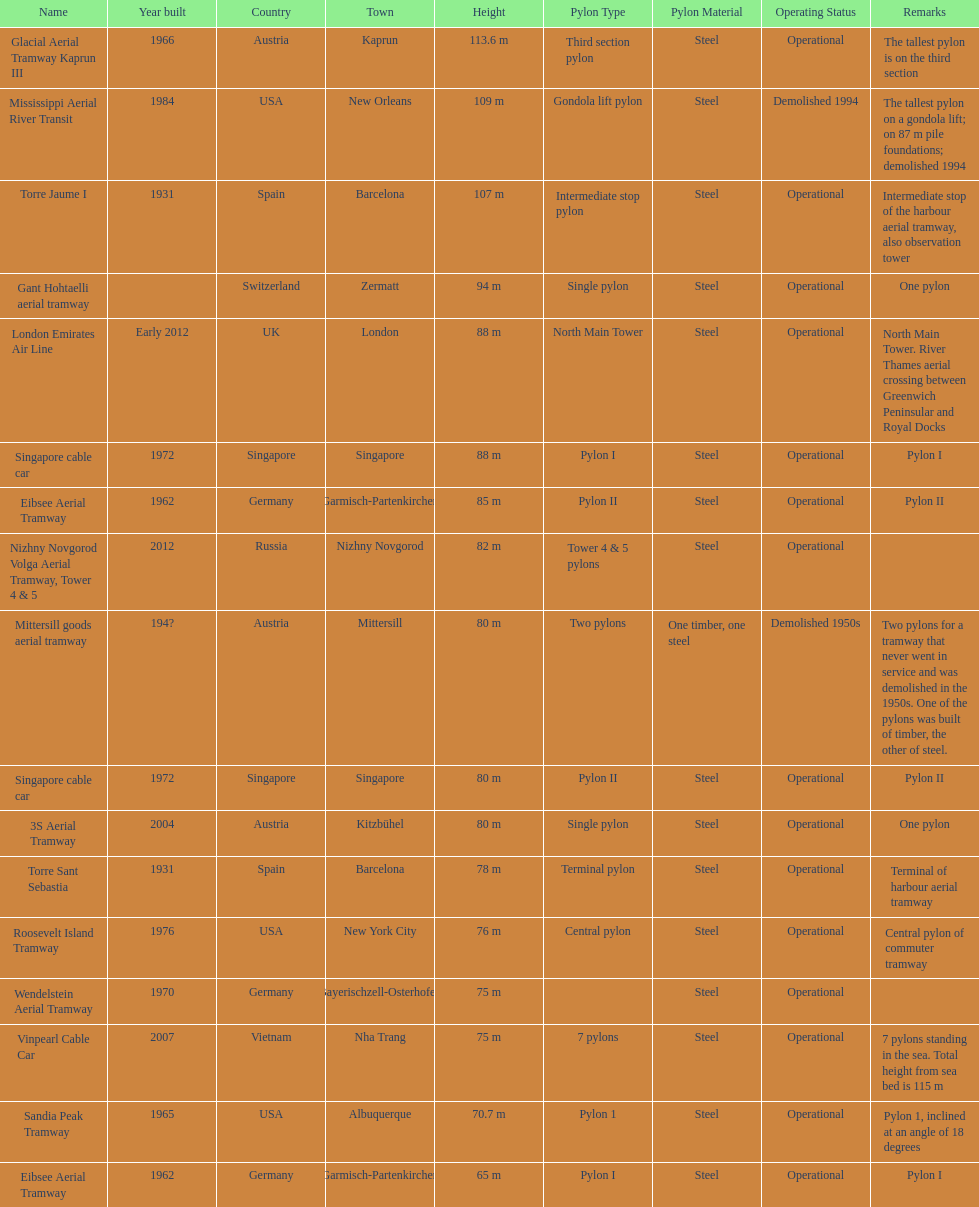How many metres is the mississippi aerial river transit from bottom to top? 109 m. 